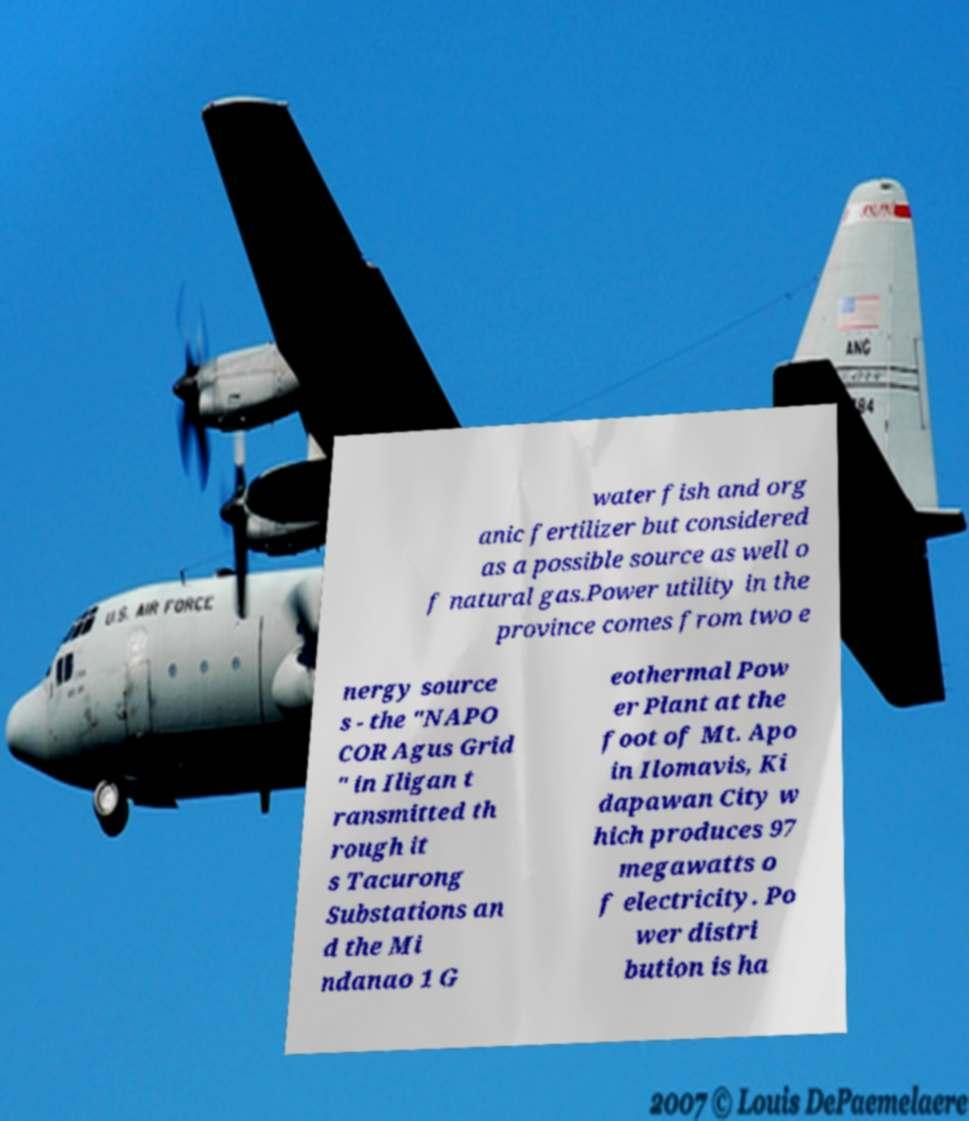Please identify and transcribe the text found in this image. water fish and org anic fertilizer but considered as a possible source as well o f natural gas.Power utility in the province comes from two e nergy source s - the "NAPO COR Agus Grid " in Iligan t ransmitted th rough it s Tacurong Substations an d the Mi ndanao 1 G eothermal Pow er Plant at the foot of Mt. Apo in Ilomavis, Ki dapawan City w hich produces 97 megawatts o f electricity. Po wer distri bution is ha 